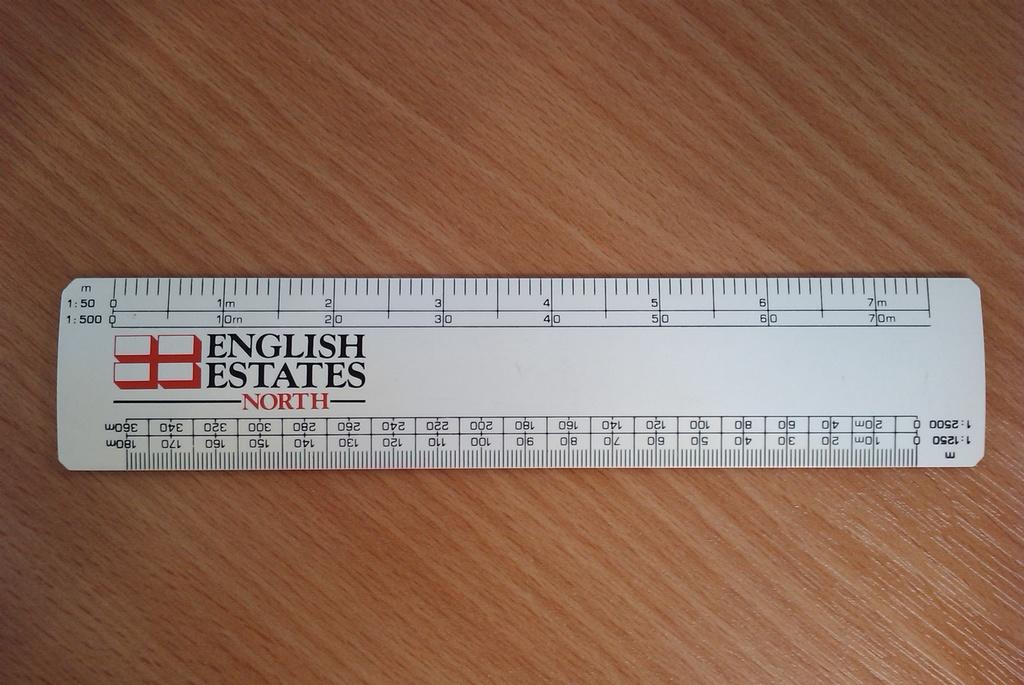What kind of estates does the ruler advertise?
Give a very brief answer. English. 